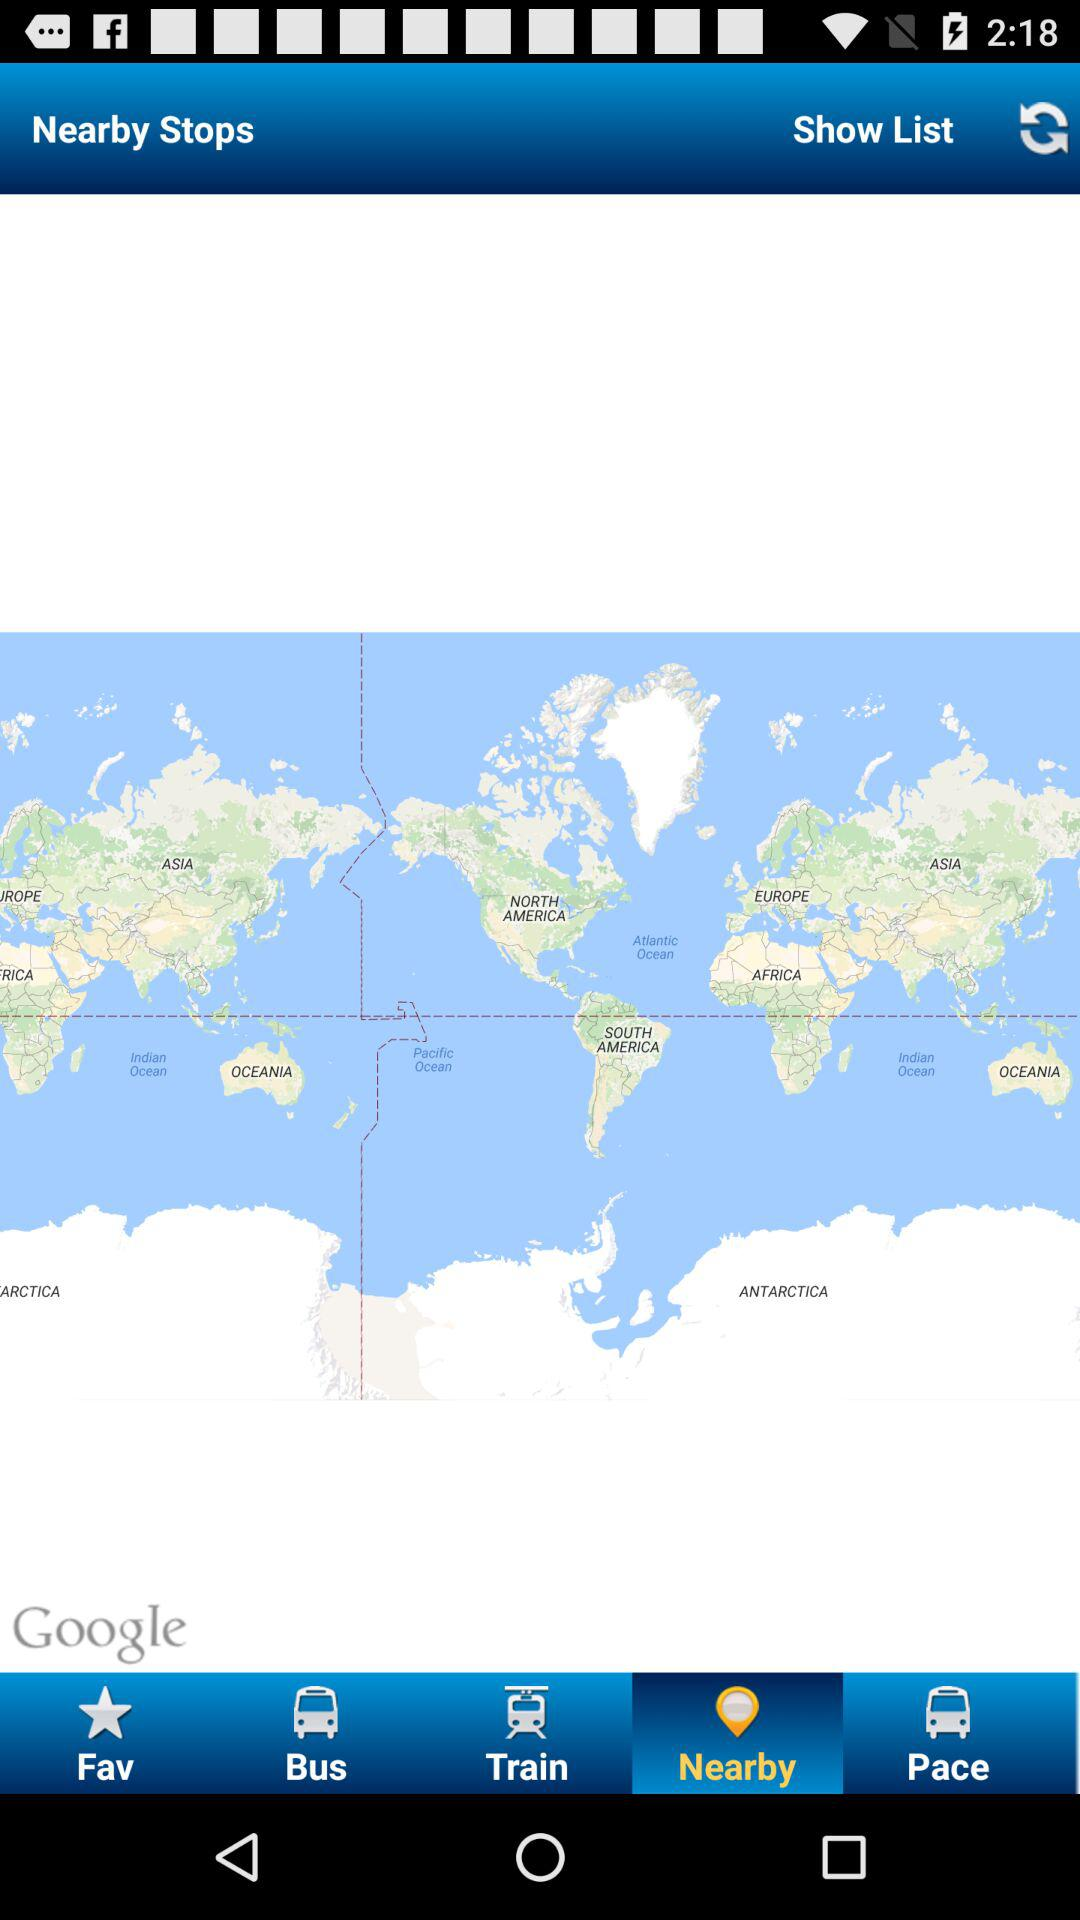Which tab has been selected? The selected tab is "Nearby". 